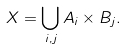<formula> <loc_0><loc_0><loc_500><loc_500>X = \bigcup _ { i , j } A _ { i } \times B _ { j } .</formula> 